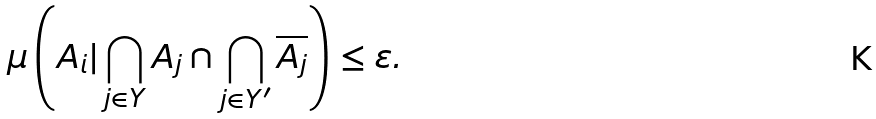<formula> <loc_0><loc_0><loc_500><loc_500>\mu \left ( A _ { i } | \bigcap _ { j \in Y } A _ { j } \cap \bigcap _ { j \in Y ^ { \prime } } \overline { A _ { j } } \right ) \leq \varepsilon .</formula> 